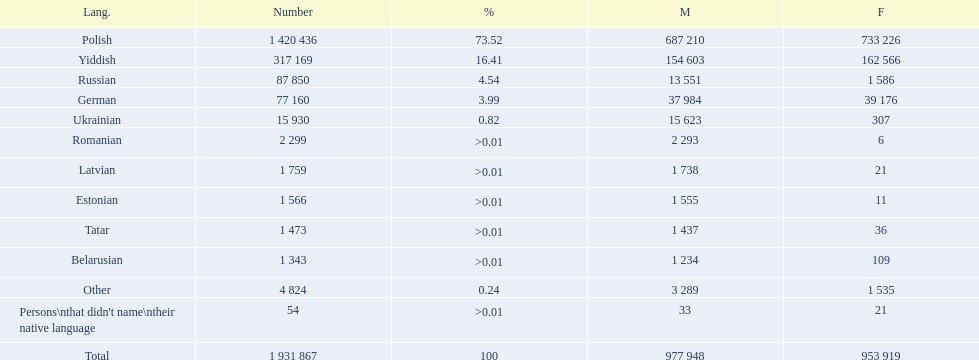What were all the languages? Polish, Yiddish, Russian, German, Ukrainian, Romanian, Latvian, Estonian, Tatar, Belarusian, Other, Persons\nthat didn't name\ntheir native language. For these, how many people spoke them? 1 420 436, 317 169, 87 850, 77 160, 15 930, 2 299, 1 759, 1 566, 1 473, 1 343, 4 824, 54. Of these, which is the largest number of speakers? 1 420 436. Which language corresponds to this number? Polish. 